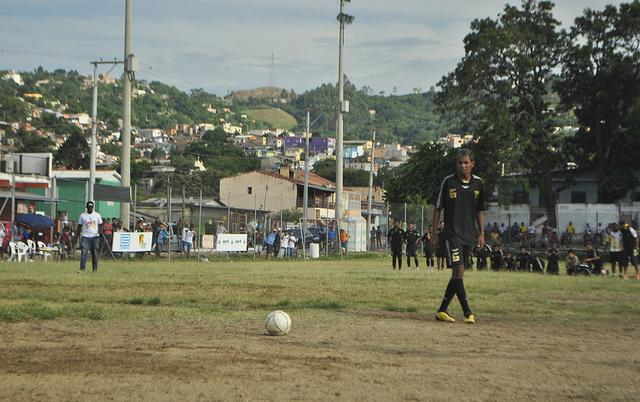What international tournament takes place every 4 years where this sport is played?

Choices:
A) world championship
B) winner's cup
C) stanley cup
D) world cup world cup 